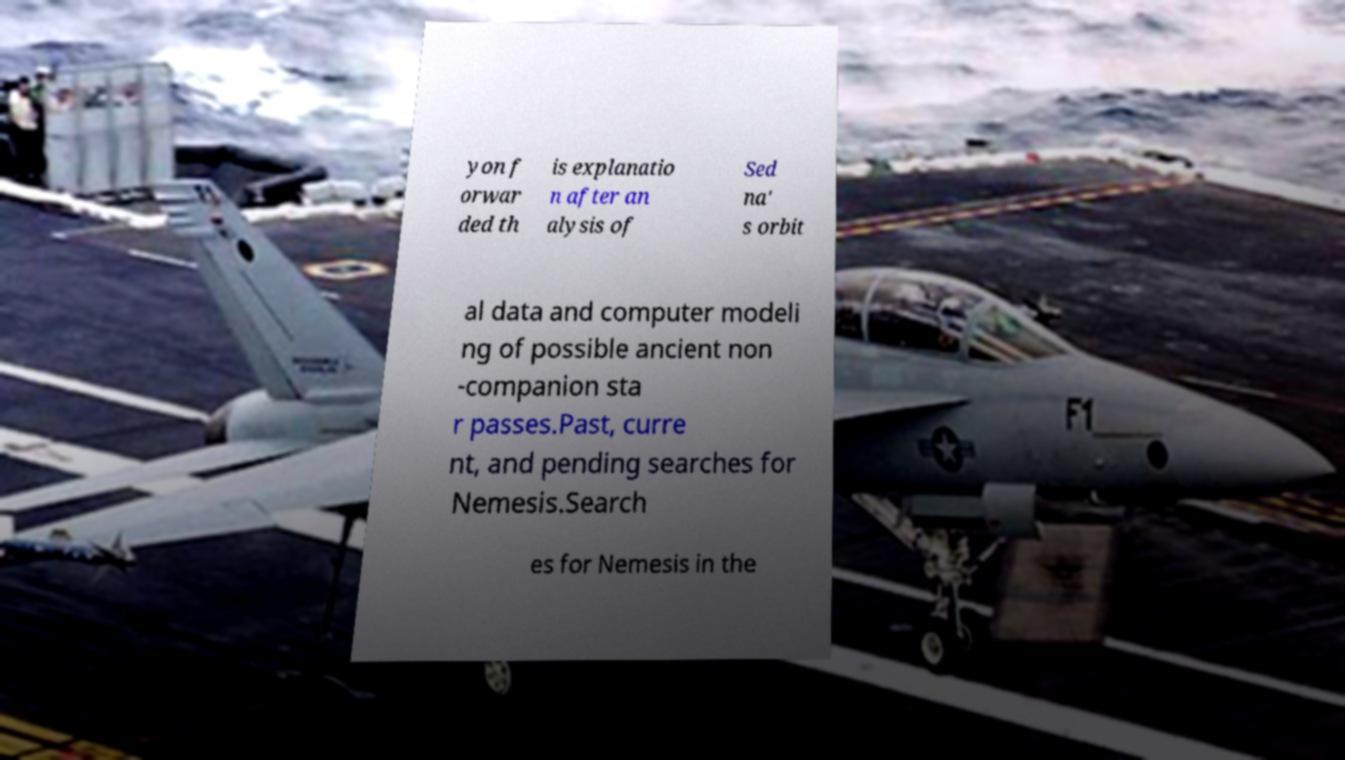Can you read and provide the text displayed in the image?This photo seems to have some interesting text. Can you extract and type it out for me? yon f orwar ded th is explanatio n after an alysis of Sed na' s orbit al data and computer modeli ng of possible ancient non -companion sta r passes.Past, curre nt, and pending searches for Nemesis.Search es for Nemesis in the 